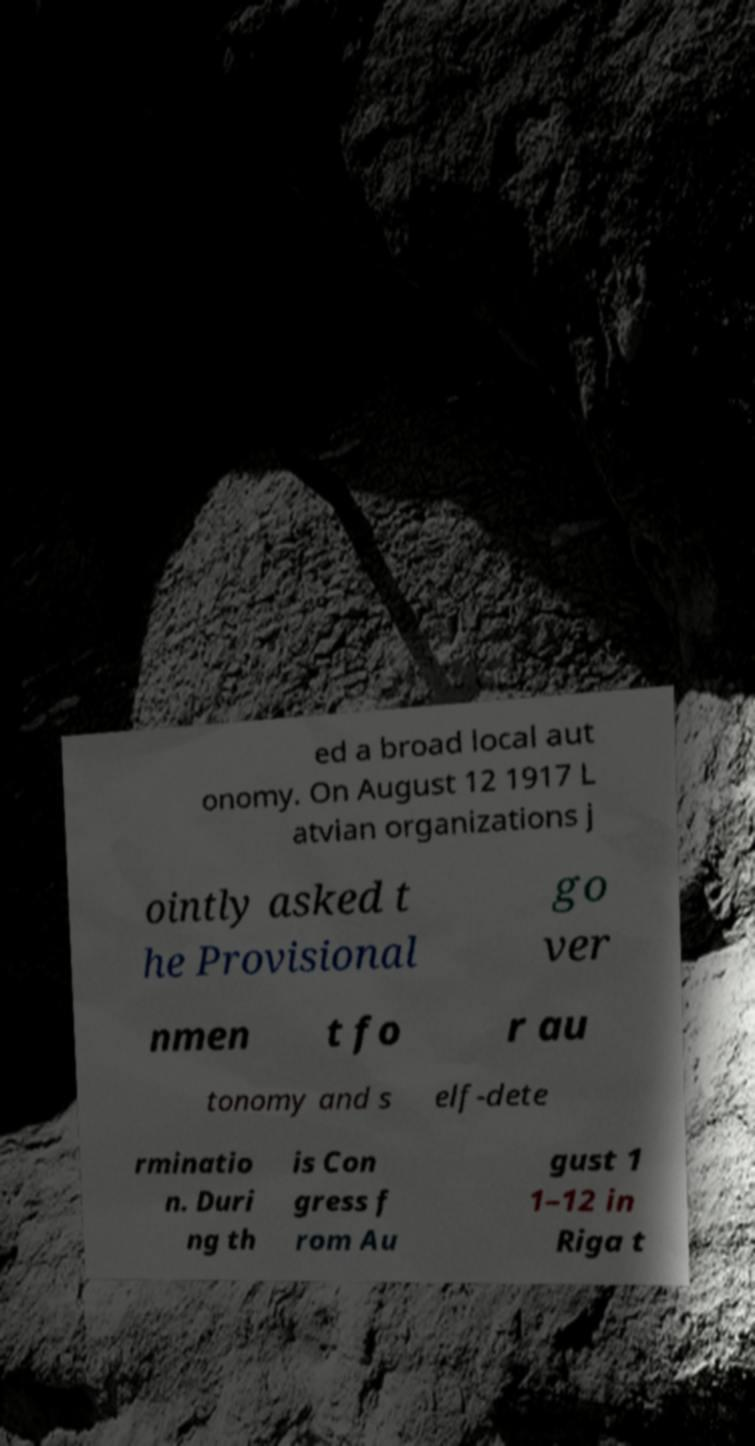Could you assist in decoding the text presented in this image and type it out clearly? ed a broad local aut onomy. On August 12 1917 L atvian organizations j ointly asked t he Provisional go ver nmen t fo r au tonomy and s elf-dete rminatio n. Duri ng th is Con gress f rom Au gust 1 1–12 in Riga t 